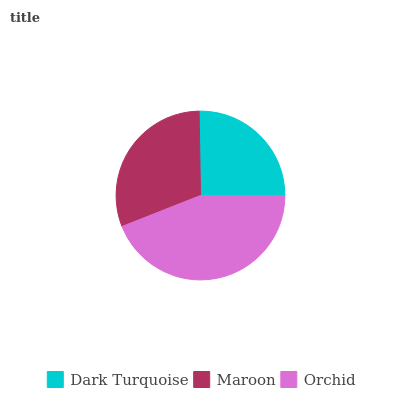Is Dark Turquoise the minimum?
Answer yes or no. Yes. Is Orchid the maximum?
Answer yes or no. Yes. Is Maroon the minimum?
Answer yes or no. No. Is Maroon the maximum?
Answer yes or no. No. Is Maroon greater than Dark Turquoise?
Answer yes or no. Yes. Is Dark Turquoise less than Maroon?
Answer yes or no. Yes. Is Dark Turquoise greater than Maroon?
Answer yes or no. No. Is Maroon less than Dark Turquoise?
Answer yes or no. No. Is Maroon the high median?
Answer yes or no. Yes. Is Maroon the low median?
Answer yes or no. Yes. Is Orchid the high median?
Answer yes or no. No. Is Dark Turquoise the low median?
Answer yes or no. No. 